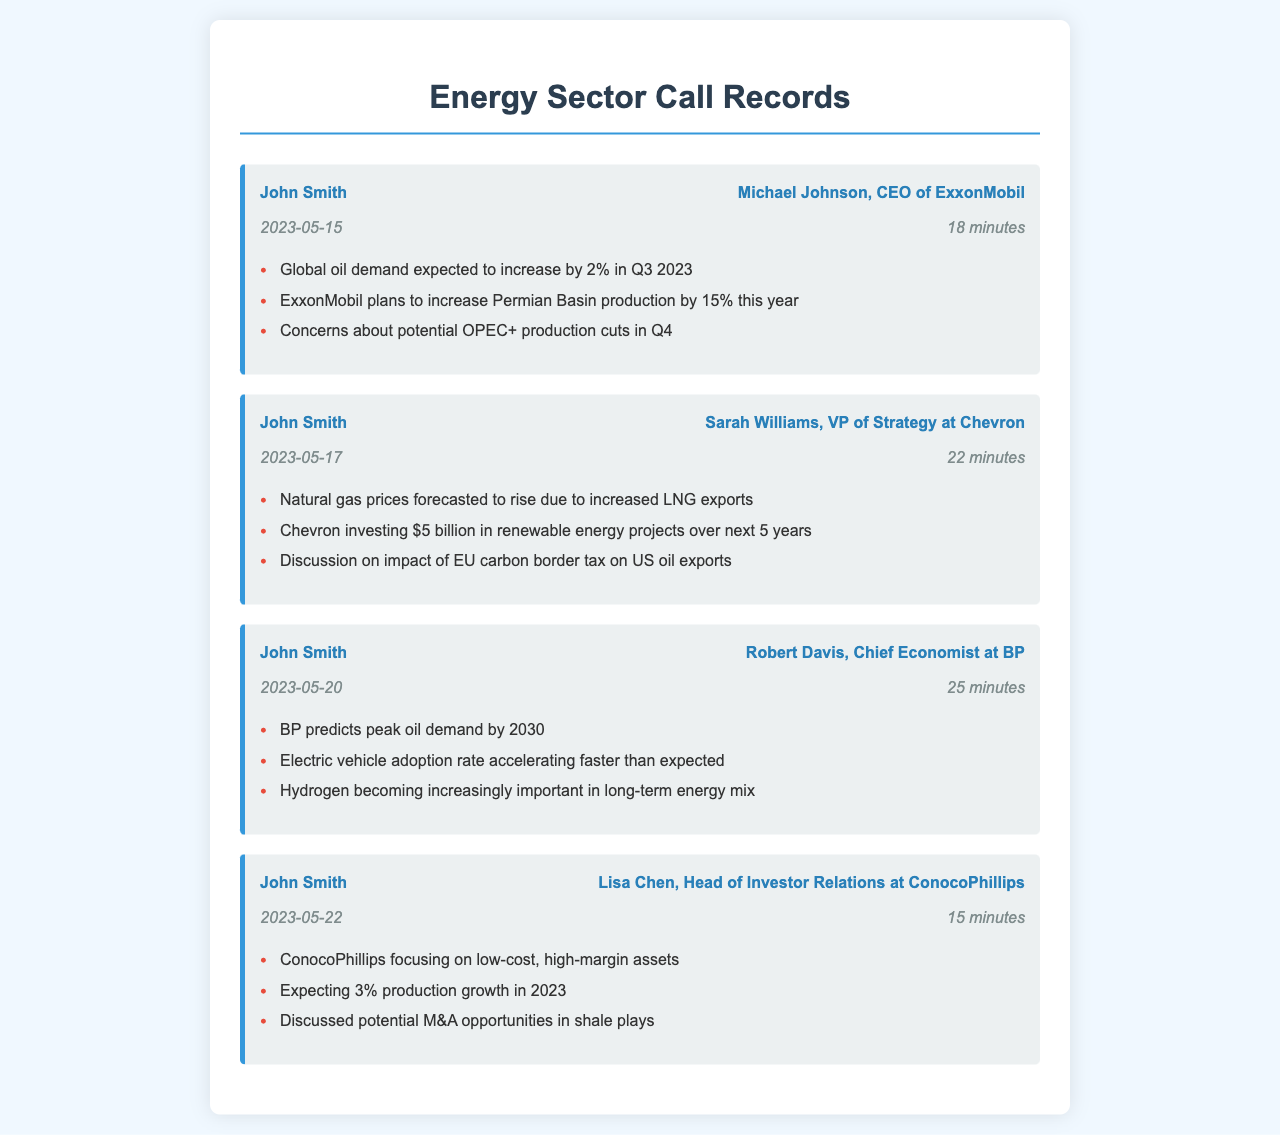what is the date of the call with ExxonMobil? The call with ExxonMobil took place on May 15, 2023.
Answer: May 15, 2023 how long was the call with Chevron? The duration of the call with Chevron was 22 minutes.
Answer: 22 minutes what is the expected increase in Permian Basin production by ExxonMobil? ExxonMobil plans to increase Permian Basin production by 15% this year.
Answer: 15% who is the Chief Economist at BP? The Chief Economist at BP is Robert Davis.
Answer: Robert Davis what is BP's prediction for peak oil demand? BP predicts peak oil demand by 2030.
Answer: 2030 which company is investing $5 billion in renewable energy projects? Chevron is investing $5 billion in renewable energy projects over the next 5 years.
Answer: Chevron what percentage production growth does ConocoPhillips expect in 2023? ConocoPhillips is expecting 3% production growth in 2023.
Answer: 3% what impact is discussed regarding EU policy during the call with Chevron? The discussion was on the impact of the EU carbon border tax on US oil exports.
Answer: EU carbon border tax what was one of the key concerns mentioned during the call with ExxonMobil? There were concerns about potential OPEC+ production cuts in Q4.
Answer: OPEC+ production cuts which energy source is becoming increasingly important according to BP? Hydrogen is becoming increasingly important in the long-term energy mix.
Answer: Hydrogen 